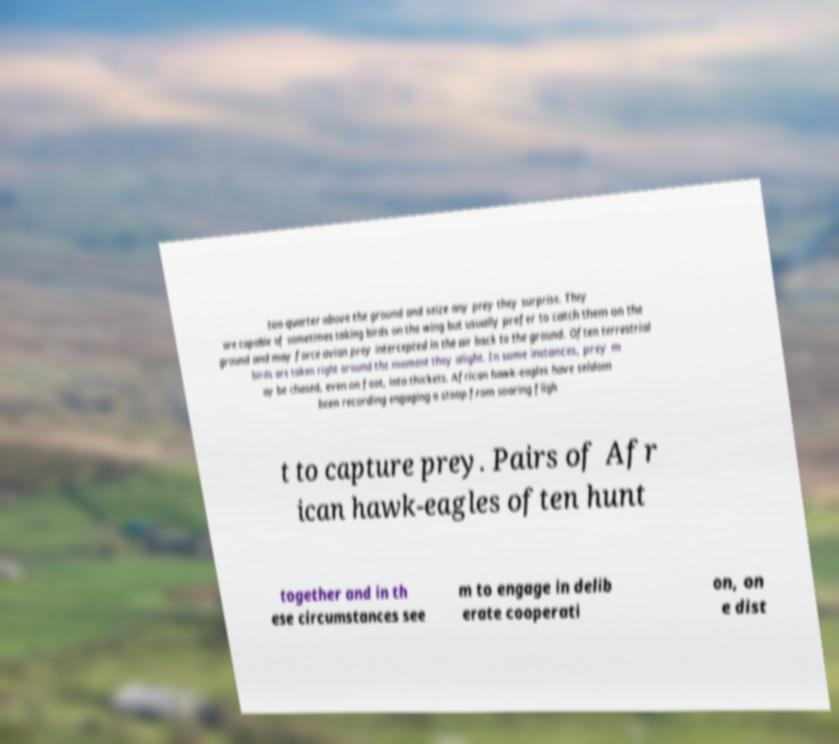For documentation purposes, I need the text within this image transcribed. Could you provide that? too quarter above the ground and seize any prey they surprise. They are capable of sometimes taking birds on the wing but usually prefer to catch them on the ground and may force avian prey intercepted in the air back to the ground. Often terrestrial birds are taken right around the moment they alight. In some instances, prey m ay be chased, even on foot, into thickets. African hawk-eagles have seldom been recording engaging a stoop from soaring fligh t to capture prey. Pairs of Afr ican hawk-eagles often hunt together and in th ese circumstances see m to engage in delib erate cooperati on, on e dist 